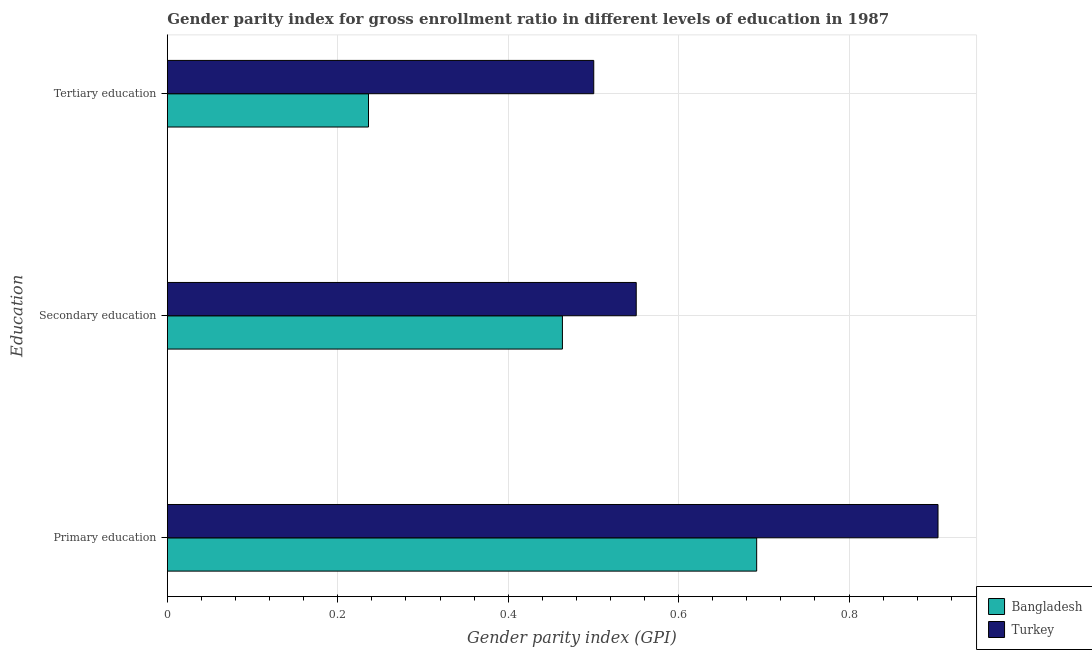How many groups of bars are there?
Give a very brief answer. 3. Are the number of bars on each tick of the Y-axis equal?
Make the answer very short. Yes. What is the label of the 3rd group of bars from the top?
Offer a terse response. Primary education. What is the gender parity index in tertiary education in Turkey?
Keep it short and to the point. 0.5. Across all countries, what is the maximum gender parity index in secondary education?
Provide a succinct answer. 0.55. Across all countries, what is the minimum gender parity index in secondary education?
Provide a succinct answer. 0.46. What is the total gender parity index in tertiary education in the graph?
Your response must be concise. 0.74. What is the difference between the gender parity index in primary education in Turkey and that in Bangladesh?
Your answer should be compact. 0.21. What is the difference between the gender parity index in tertiary education in Turkey and the gender parity index in secondary education in Bangladesh?
Provide a short and direct response. 0.04. What is the average gender parity index in primary education per country?
Your response must be concise. 0.8. What is the difference between the gender parity index in secondary education and gender parity index in tertiary education in Bangladesh?
Your answer should be compact. 0.23. What is the ratio of the gender parity index in tertiary education in Bangladesh to that in Turkey?
Ensure brevity in your answer.  0.47. Is the difference between the gender parity index in secondary education in Bangladesh and Turkey greater than the difference between the gender parity index in tertiary education in Bangladesh and Turkey?
Your answer should be compact. Yes. What is the difference between the highest and the second highest gender parity index in secondary education?
Provide a succinct answer. 0.09. What is the difference between the highest and the lowest gender parity index in secondary education?
Offer a terse response. 0.09. In how many countries, is the gender parity index in primary education greater than the average gender parity index in primary education taken over all countries?
Provide a succinct answer. 1. What does the 2nd bar from the top in Tertiary education represents?
Provide a short and direct response. Bangladesh. What does the 2nd bar from the bottom in Tertiary education represents?
Your answer should be compact. Turkey. Is it the case that in every country, the sum of the gender parity index in primary education and gender parity index in secondary education is greater than the gender parity index in tertiary education?
Ensure brevity in your answer.  Yes. How many countries are there in the graph?
Keep it short and to the point. 2. What is the difference between two consecutive major ticks on the X-axis?
Provide a succinct answer. 0.2. Are the values on the major ticks of X-axis written in scientific E-notation?
Provide a short and direct response. No. Where does the legend appear in the graph?
Provide a short and direct response. Bottom right. What is the title of the graph?
Give a very brief answer. Gender parity index for gross enrollment ratio in different levels of education in 1987. What is the label or title of the X-axis?
Ensure brevity in your answer.  Gender parity index (GPI). What is the label or title of the Y-axis?
Your answer should be very brief. Education. What is the Gender parity index (GPI) in Bangladesh in Primary education?
Give a very brief answer. 0.69. What is the Gender parity index (GPI) of Turkey in Primary education?
Your answer should be very brief. 0.9. What is the Gender parity index (GPI) of Bangladesh in Secondary education?
Keep it short and to the point. 0.46. What is the Gender parity index (GPI) in Turkey in Secondary education?
Provide a succinct answer. 0.55. What is the Gender parity index (GPI) of Bangladesh in Tertiary education?
Offer a terse response. 0.24. What is the Gender parity index (GPI) of Turkey in Tertiary education?
Offer a very short reply. 0.5. Across all Education, what is the maximum Gender parity index (GPI) in Bangladesh?
Provide a succinct answer. 0.69. Across all Education, what is the maximum Gender parity index (GPI) of Turkey?
Give a very brief answer. 0.9. Across all Education, what is the minimum Gender parity index (GPI) in Bangladesh?
Your answer should be compact. 0.24. Across all Education, what is the minimum Gender parity index (GPI) in Turkey?
Offer a terse response. 0.5. What is the total Gender parity index (GPI) of Bangladesh in the graph?
Your answer should be compact. 1.39. What is the total Gender parity index (GPI) in Turkey in the graph?
Provide a short and direct response. 1.96. What is the difference between the Gender parity index (GPI) in Bangladesh in Primary education and that in Secondary education?
Offer a very short reply. 0.23. What is the difference between the Gender parity index (GPI) in Turkey in Primary education and that in Secondary education?
Provide a short and direct response. 0.35. What is the difference between the Gender parity index (GPI) of Bangladesh in Primary education and that in Tertiary education?
Your answer should be very brief. 0.46. What is the difference between the Gender parity index (GPI) in Turkey in Primary education and that in Tertiary education?
Make the answer very short. 0.4. What is the difference between the Gender parity index (GPI) in Bangladesh in Secondary education and that in Tertiary education?
Your answer should be compact. 0.23. What is the difference between the Gender parity index (GPI) in Turkey in Secondary education and that in Tertiary education?
Your response must be concise. 0.05. What is the difference between the Gender parity index (GPI) of Bangladesh in Primary education and the Gender parity index (GPI) of Turkey in Secondary education?
Offer a terse response. 0.14. What is the difference between the Gender parity index (GPI) of Bangladesh in Primary education and the Gender parity index (GPI) of Turkey in Tertiary education?
Your answer should be very brief. 0.19. What is the difference between the Gender parity index (GPI) in Bangladesh in Secondary education and the Gender parity index (GPI) in Turkey in Tertiary education?
Give a very brief answer. -0.04. What is the average Gender parity index (GPI) of Bangladesh per Education?
Ensure brevity in your answer.  0.46. What is the average Gender parity index (GPI) of Turkey per Education?
Provide a short and direct response. 0.65. What is the difference between the Gender parity index (GPI) of Bangladesh and Gender parity index (GPI) of Turkey in Primary education?
Offer a very short reply. -0.21. What is the difference between the Gender parity index (GPI) in Bangladesh and Gender parity index (GPI) in Turkey in Secondary education?
Give a very brief answer. -0.09. What is the difference between the Gender parity index (GPI) of Bangladesh and Gender parity index (GPI) of Turkey in Tertiary education?
Offer a very short reply. -0.26. What is the ratio of the Gender parity index (GPI) in Bangladesh in Primary education to that in Secondary education?
Ensure brevity in your answer.  1.49. What is the ratio of the Gender parity index (GPI) in Turkey in Primary education to that in Secondary education?
Ensure brevity in your answer.  1.64. What is the ratio of the Gender parity index (GPI) of Bangladesh in Primary education to that in Tertiary education?
Offer a terse response. 2.93. What is the ratio of the Gender parity index (GPI) in Turkey in Primary education to that in Tertiary education?
Keep it short and to the point. 1.81. What is the ratio of the Gender parity index (GPI) of Bangladesh in Secondary education to that in Tertiary education?
Your response must be concise. 1.96. What is the ratio of the Gender parity index (GPI) of Turkey in Secondary education to that in Tertiary education?
Offer a very short reply. 1.1. What is the difference between the highest and the second highest Gender parity index (GPI) of Bangladesh?
Ensure brevity in your answer.  0.23. What is the difference between the highest and the second highest Gender parity index (GPI) in Turkey?
Give a very brief answer. 0.35. What is the difference between the highest and the lowest Gender parity index (GPI) in Bangladesh?
Provide a succinct answer. 0.46. What is the difference between the highest and the lowest Gender parity index (GPI) of Turkey?
Give a very brief answer. 0.4. 